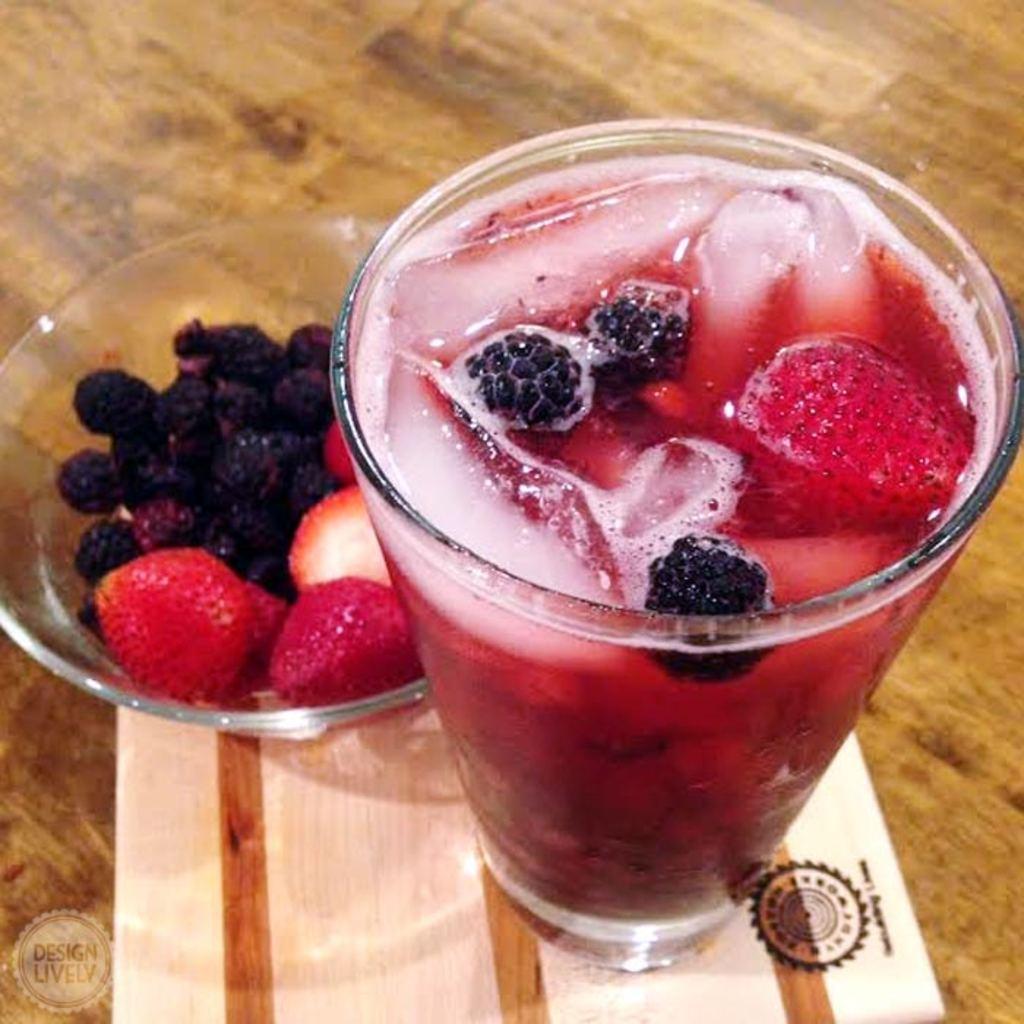How would you summarize this image in a sentence or two? In this picture I can observe a glass and a bowl. I can observe juice in the glass and fruits in the bowl. These are placed on the brown color table. 